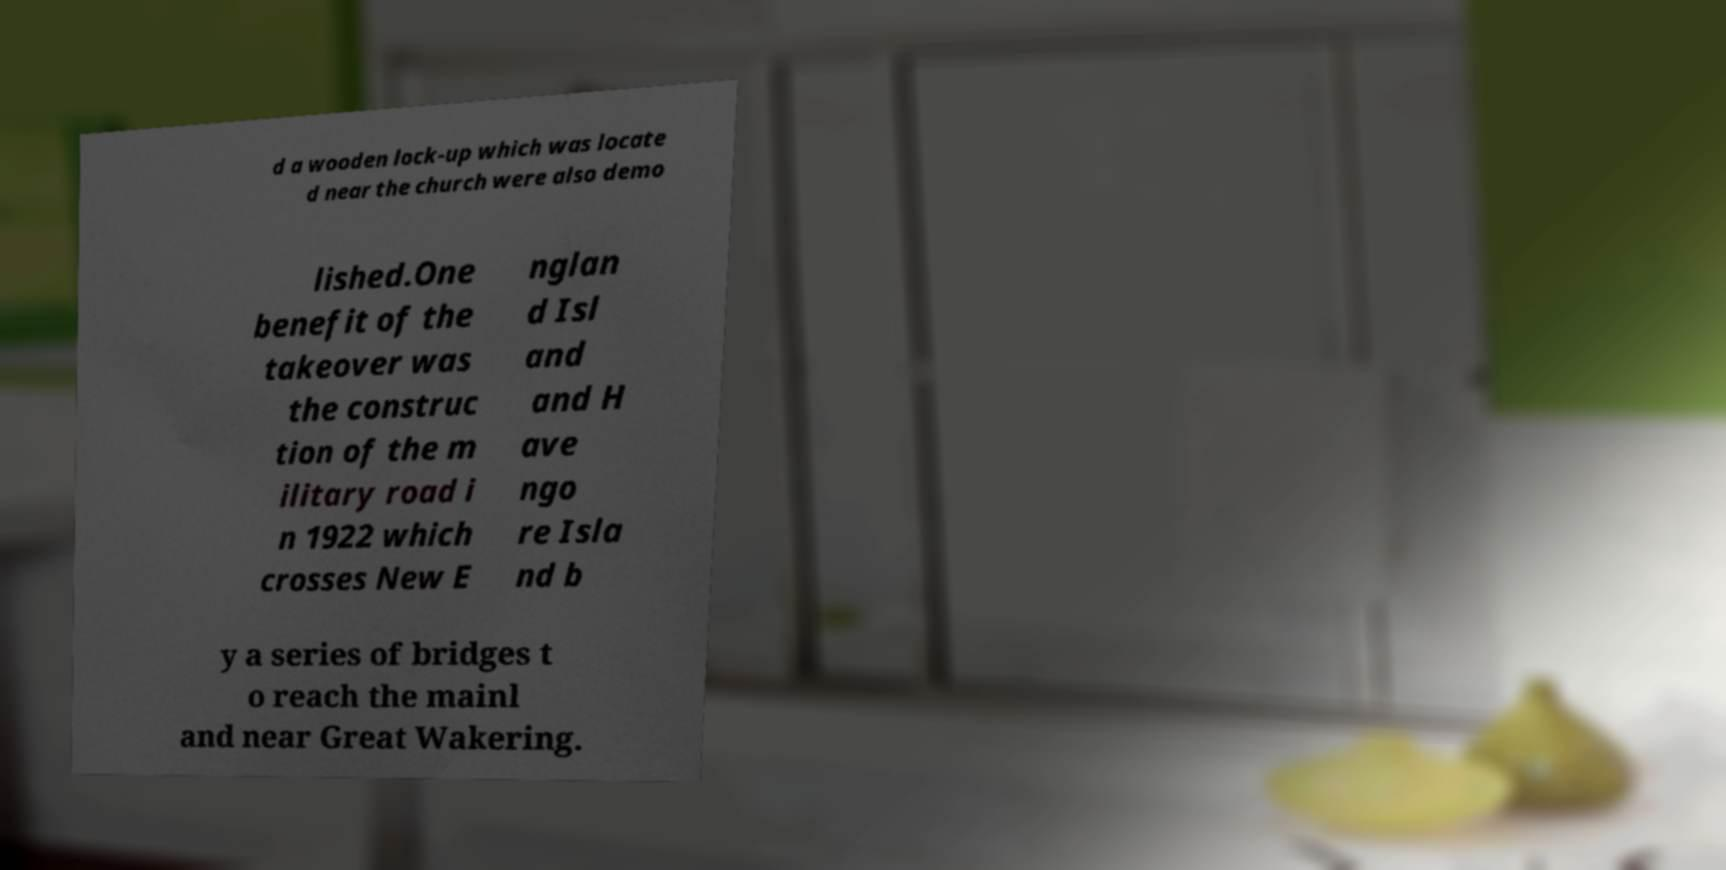Please read and relay the text visible in this image. What does it say? d a wooden lock-up which was locate d near the church were also demo lished.One benefit of the takeover was the construc tion of the m ilitary road i n 1922 which crosses New E nglan d Isl and and H ave ngo re Isla nd b y a series of bridges t o reach the mainl and near Great Wakering. 